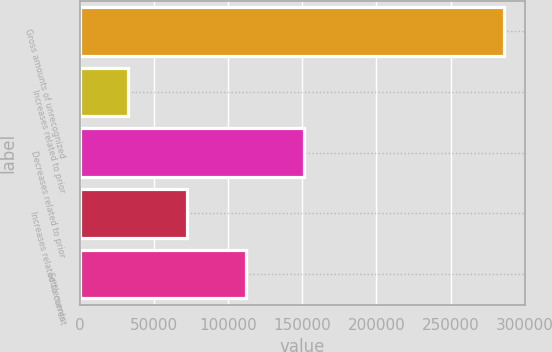Convert chart. <chart><loc_0><loc_0><loc_500><loc_500><bar_chart><fcel>Gross amounts of unrecognized<fcel>Increases related to prior<fcel>Decreases related to prior<fcel>Increases related to current<fcel>Settlements<nl><fcel>285720<fcel>32582<fcel>151311<fcel>72158.2<fcel>111734<nl></chart> 